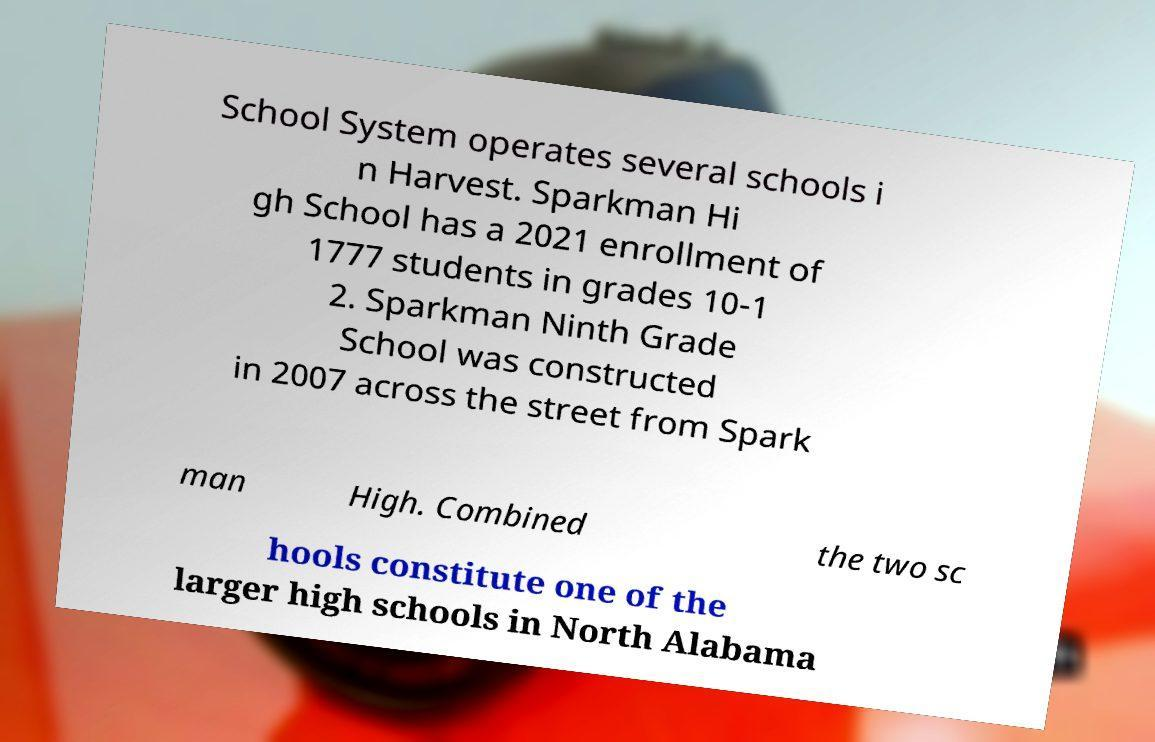Could you extract and type out the text from this image? School System operates several schools i n Harvest. Sparkman Hi gh School has a 2021 enrollment of 1777 students in grades 10-1 2. Sparkman Ninth Grade School was constructed in 2007 across the street from Spark man High. Combined the two sc hools constitute one of the larger high schools in North Alabama 